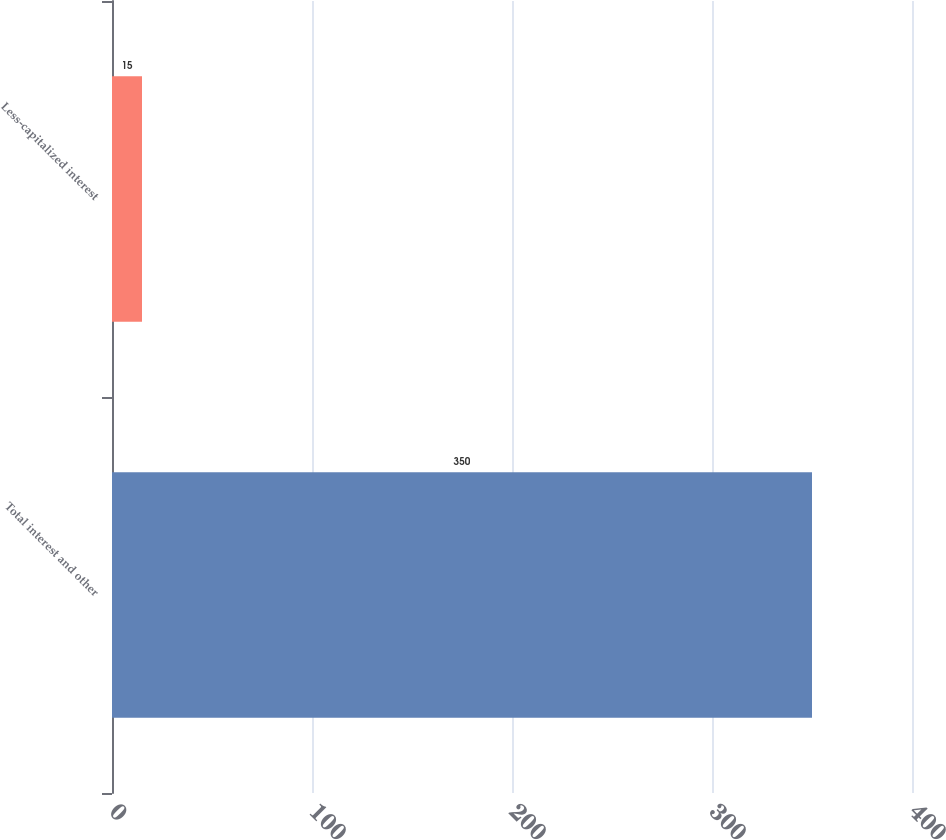Convert chart. <chart><loc_0><loc_0><loc_500><loc_500><bar_chart><fcel>Total interest and other<fcel>Less-capitalized interest<nl><fcel>350<fcel>15<nl></chart> 